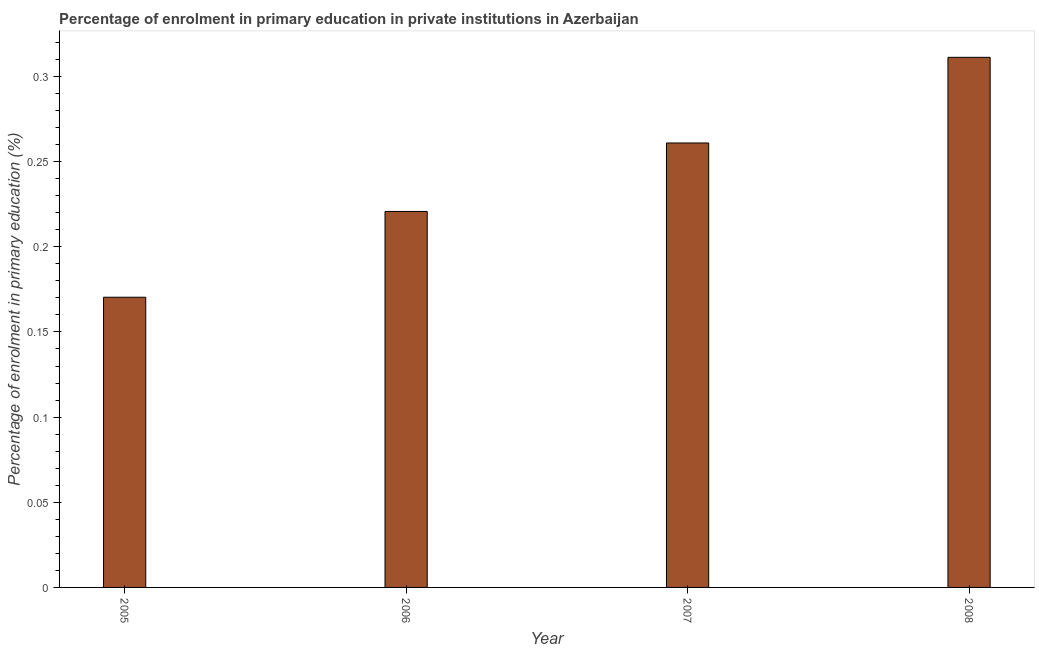Does the graph contain any zero values?
Your response must be concise. No. What is the title of the graph?
Provide a succinct answer. Percentage of enrolment in primary education in private institutions in Azerbaijan. What is the label or title of the X-axis?
Offer a terse response. Year. What is the label or title of the Y-axis?
Give a very brief answer. Percentage of enrolment in primary education (%). What is the enrolment percentage in primary education in 2007?
Make the answer very short. 0.26. Across all years, what is the maximum enrolment percentage in primary education?
Offer a terse response. 0.31. Across all years, what is the minimum enrolment percentage in primary education?
Offer a very short reply. 0.17. What is the sum of the enrolment percentage in primary education?
Give a very brief answer. 0.96. What is the difference between the enrolment percentage in primary education in 2007 and 2008?
Ensure brevity in your answer.  -0.05. What is the average enrolment percentage in primary education per year?
Your response must be concise. 0.24. What is the median enrolment percentage in primary education?
Offer a terse response. 0.24. In how many years, is the enrolment percentage in primary education greater than 0.31 %?
Your response must be concise. 1. Do a majority of the years between 2006 and 2007 (inclusive) have enrolment percentage in primary education greater than 0.12 %?
Offer a very short reply. Yes. What is the ratio of the enrolment percentage in primary education in 2005 to that in 2006?
Your answer should be very brief. 0.77. What is the difference between the highest and the second highest enrolment percentage in primary education?
Your response must be concise. 0.05. Is the sum of the enrolment percentage in primary education in 2006 and 2007 greater than the maximum enrolment percentage in primary education across all years?
Your answer should be compact. Yes. What is the difference between the highest and the lowest enrolment percentage in primary education?
Your answer should be compact. 0.14. In how many years, is the enrolment percentage in primary education greater than the average enrolment percentage in primary education taken over all years?
Your answer should be very brief. 2. How many bars are there?
Ensure brevity in your answer.  4. What is the Percentage of enrolment in primary education (%) of 2005?
Offer a very short reply. 0.17. What is the Percentage of enrolment in primary education (%) of 2006?
Keep it short and to the point. 0.22. What is the Percentage of enrolment in primary education (%) in 2007?
Provide a short and direct response. 0.26. What is the Percentage of enrolment in primary education (%) in 2008?
Keep it short and to the point. 0.31. What is the difference between the Percentage of enrolment in primary education (%) in 2005 and 2006?
Offer a terse response. -0.05. What is the difference between the Percentage of enrolment in primary education (%) in 2005 and 2007?
Make the answer very short. -0.09. What is the difference between the Percentage of enrolment in primary education (%) in 2005 and 2008?
Offer a very short reply. -0.14. What is the difference between the Percentage of enrolment in primary education (%) in 2006 and 2007?
Your answer should be compact. -0.04. What is the difference between the Percentage of enrolment in primary education (%) in 2006 and 2008?
Your response must be concise. -0.09. What is the difference between the Percentage of enrolment in primary education (%) in 2007 and 2008?
Your response must be concise. -0.05. What is the ratio of the Percentage of enrolment in primary education (%) in 2005 to that in 2006?
Give a very brief answer. 0.77. What is the ratio of the Percentage of enrolment in primary education (%) in 2005 to that in 2007?
Keep it short and to the point. 0.65. What is the ratio of the Percentage of enrolment in primary education (%) in 2005 to that in 2008?
Your response must be concise. 0.55. What is the ratio of the Percentage of enrolment in primary education (%) in 2006 to that in 2007?
Provide a short and direct response. 0.85. What is the ratio of the Percentage of enrolment in primary education (%) in 2006 to that in 2008?
Give a very brief answer. 0.71. What is the ratio of the Percentage of enrolment in primary education (%) in 2007 to that in 2008?
Provide a succinct answer. 0.84. 